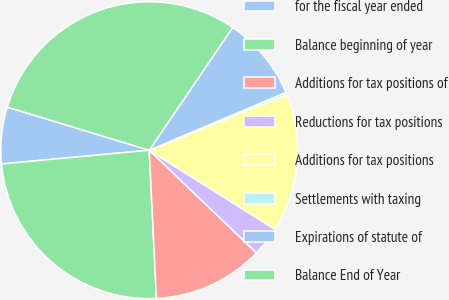Convert chart. <chart><loc_0><loc_0><loc_500><loc_500><pie_chart><fcel>for the fiscal year ended<fcel>Balance beginning of year<fcel>Additions for tax positions of<fcel>Reductions for tax positions<fcel>Additions for tax positions<fcel>Settlements with taxing<fcel>Expirations of statute of<fcel>Balance End of Year<nl><fcel>6.17%<fcel>24.29%<fcel>12.08%<fcel>3.22%<fcel>15.04%<fcel>0.26%<fcel>9.13%<fcel>29.81%<nl></chart> 